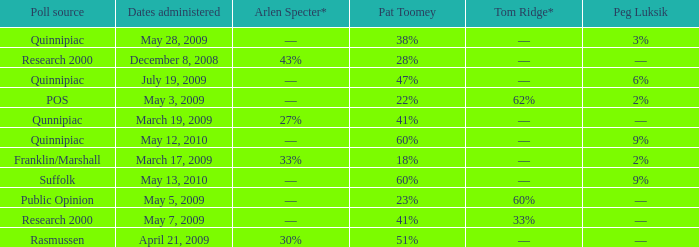Which Tom Ridge* has a Poll source of research 2000, and an Arlen Specter* of 43%? ––. 